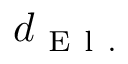<formula> <loc_0><loc_0><loc_500><loc_500>d _ { E l . }</formula> 